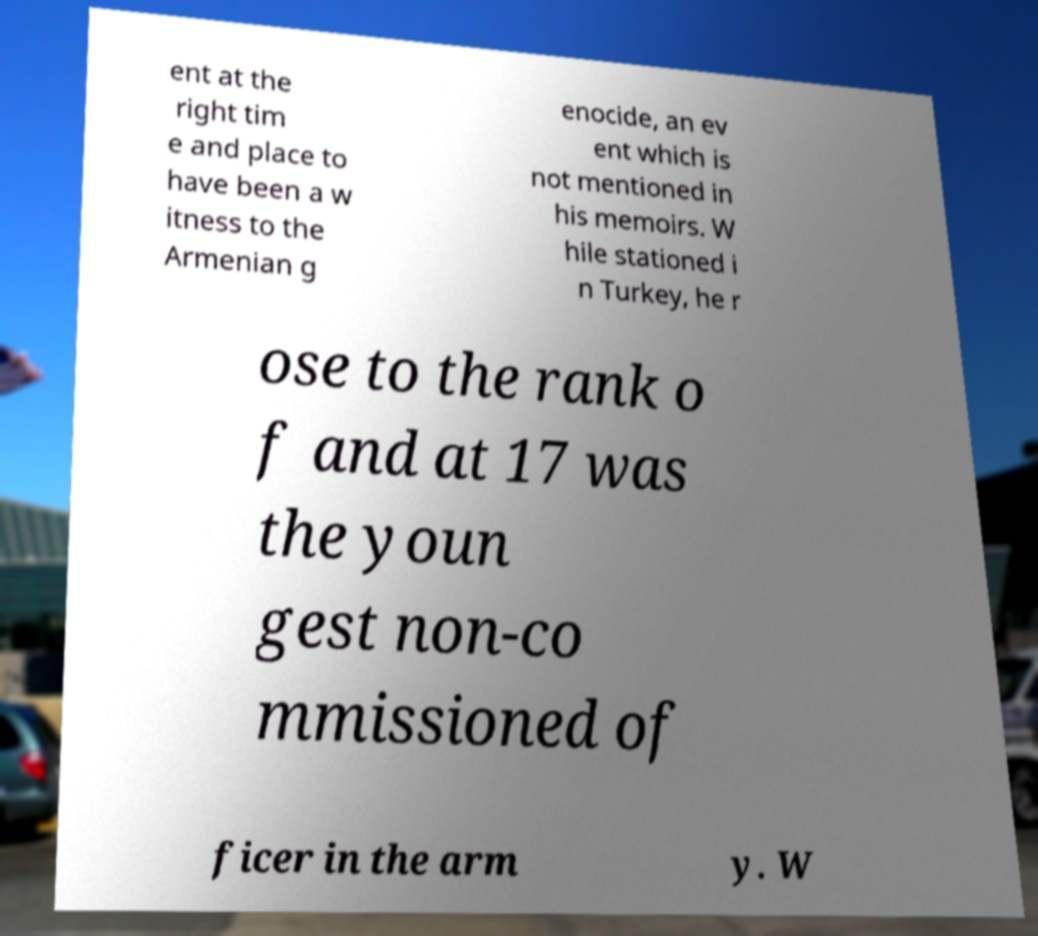Can you accurately transcribe the text from the provided image for me? ent at the right tim e and place to have been a w itness to the Armenian g enocide, an ev ent which is not mentioned in his memoirs. W hile stationed i n Turkey, he r ose to the rank o f and at 17 was the youn gest non-co mmissioned of ficer in the arm y. W 